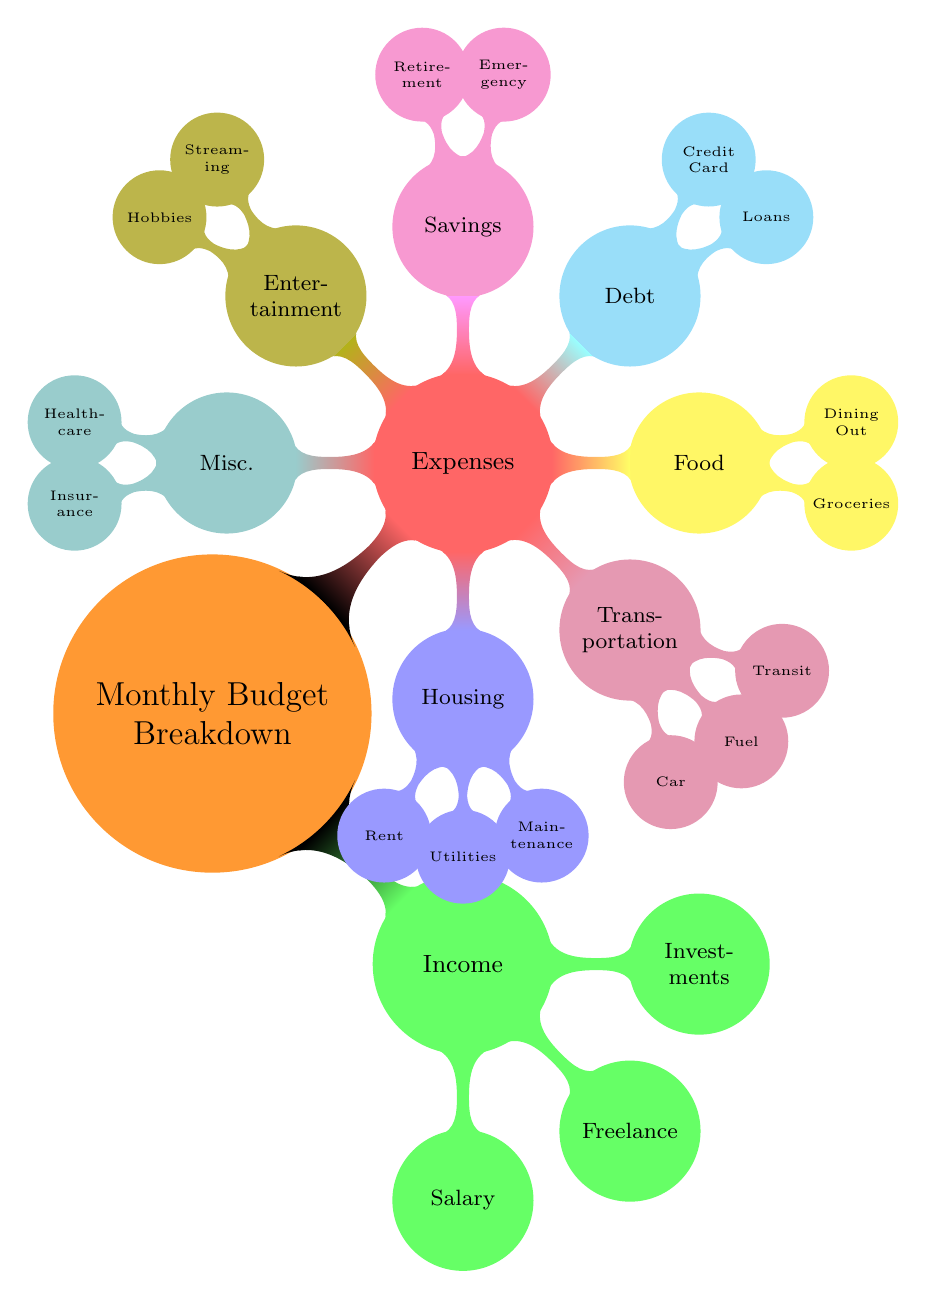What are the main categories in the monthly budget breakdown? The main categories are Income and Expenses, visualized as the two primary branches of the mind map.
Answer: Income, Expenses How many subcategories are under Expenses? Under the Expenses category, there are seven identified subcategories: Housing, Transportation, Food, Debt Repayment, Savings & Investments, Entertainment, and Miscellaneous. Counting these gives a total of seven.
Answer: 7 What is the color of the Income node? The Income node is represented in green color within the mind map, specifically colored by its designated style.
Answer: Green Which node is directly connected to Housing? The nodes directly connected to Housing are Rent, Utilities, and Maintenance; these are the specific expense types categorized under Housing.
Answer: Rent, Utilities, Maintenance What subcategory falls under Savings & Investments? The subcategories under Savings & Investments are Emergency Fund and Retirement Fund (401k/IRA), which detail specific types of savings.
Answer: Emergency Fund, Retirement Fund How many types of Transportation expenses are listed? There are four types of Transportation expenses shown in the diagram: Car Payments, Fuel, Public Transit, and Insurance. Hence, the total is four.
Answer: 4 Which category includes Hobbies? Hobbies are included under the Entertainment category, which details various leisure activities associated with spending.
Answer: Entertainment What are the two types of Debt Repayment listed? The two types of Debt Repayment listed are Student Loans and Credit Card Payments, which represent common debt obligations.
Answer: Student Loans, Credit Card Payments What type of budgeting activity falls under Miscellaneous? Under Miscellaneous, the budgeting activities include Healthcare, Insurance (Health, Life, Disability), and Personal Care, which address a range of non-categorized expenditures.
Answer: Healthcare, Insurance, Personal Care 